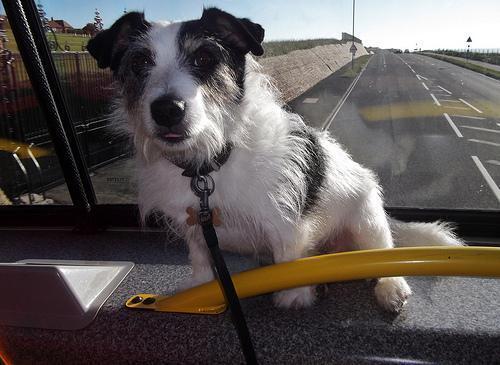How many dogs are there?
Give a very brief answer. 1. 